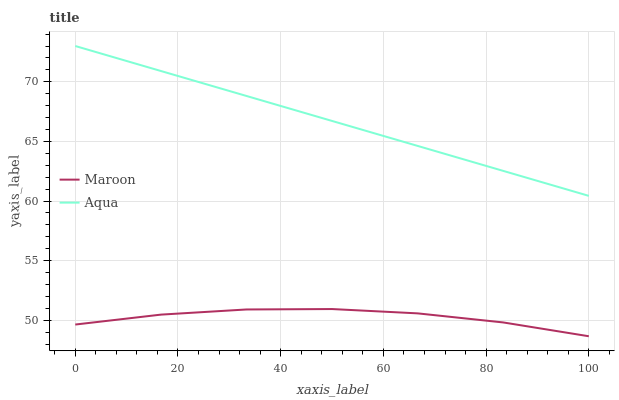Does Maroon have the minimum area under the curve?
Answer yes or no. Yes. Does Aqua have the maximum area under the curve?
Answer yes or no. Yes. Does Maroon have the maximum area under the curve?
Answer yes or no. No. Is Aqua the smoothest?
Answer yes or no. Yes. Is Maroon the roughest?
Answer yes or no. Yes. Is Maroon the smoothest?
Answer yes or no. No. Does Maroon have the lowest value?
Answer yes or no. Yes. Does Aqua have the highest value?
Answer yes or no. Yes. Does Maroon have the highest value?
Answer yes or no. No. Is Maroon less than Aqua?
Answer yes or no. Yes. Is Aqua greater than Maroon?
Answer yes or no. Yes. Does Maroon intersect Aqua?
Answer yes or no. No. 